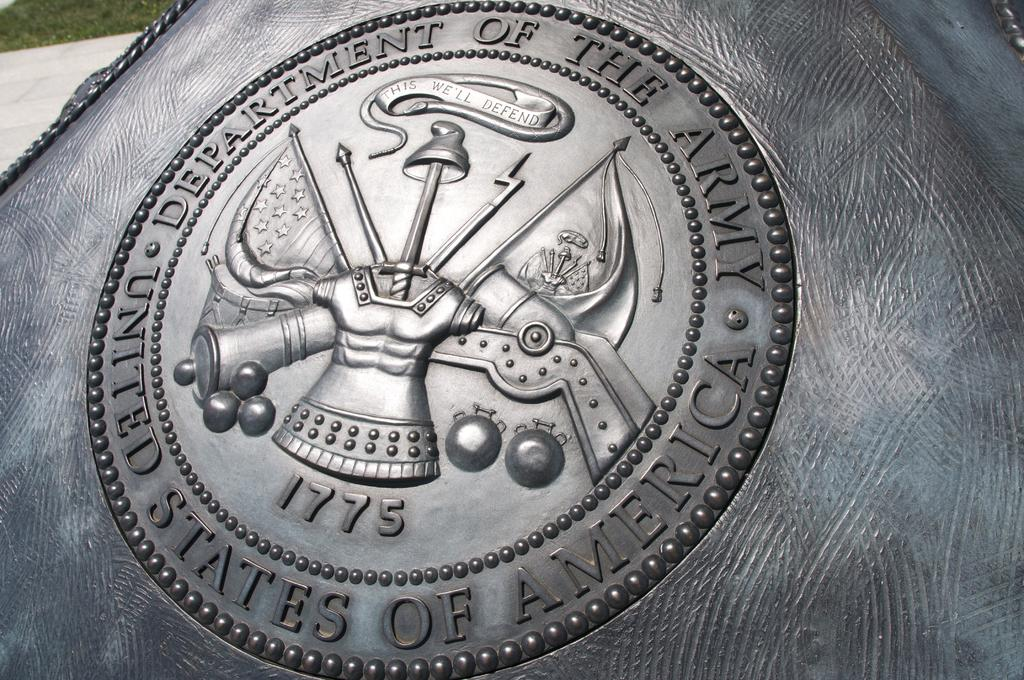<image>
Create a compact narrative representing the image presented. a US department of army symbol is into leather 